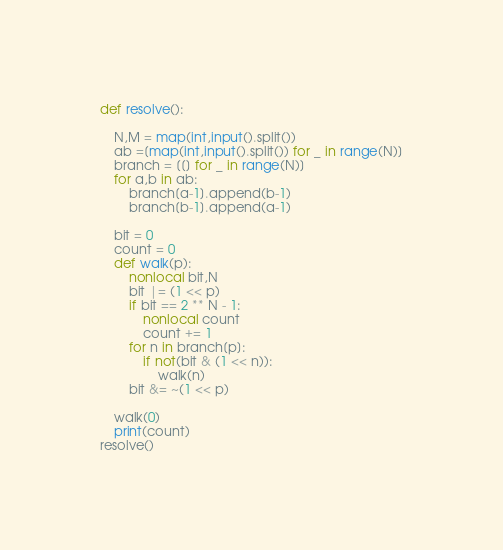<code> <loc_0><loc_0><loc_500><loc_500><_Python_>def resolve():

    N,M = map(int,input().split())
    ab =[map(int,input().split()) for _ in range(N)]
    branch = [[] for _ in range(N)]
    for a,b in ab:
        branch[a-1].append(b-1)
        branch[b-1].append(a-1)
    
    bit = 0
    count = 0
    def walk(p):
        nonlocal bit,N
        bit |= (1 << p)
        if bit == 2 ** N - 1:
            nonlocal count
            count += 1
        for n in branch[p]:
            if not(bit & (1 << n)):
                walk(n)
        bit &= ~(1 << p)

    walk(0)
    print(count)
resolve()</code> 